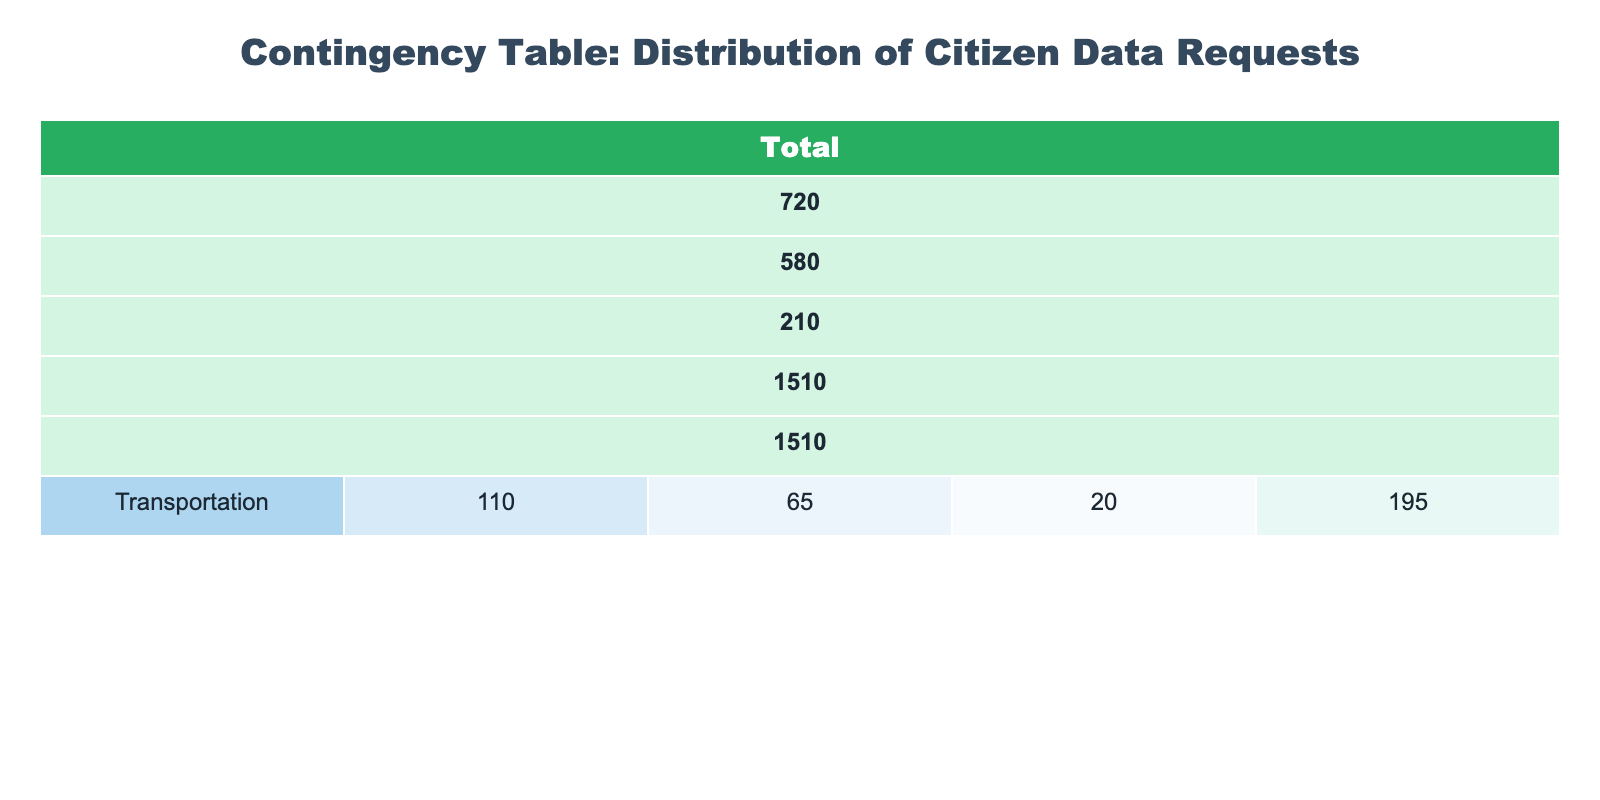What is the total number of high urgency requests across all departments? To find the total number of high urgency requests, I’ll add the values from the "High" column across all departments: 150 (Public Health) + 100 (Education) + 70 (Social Services) + 200 (Public Safety) + 90 (City Planning) + 110 (Transportation) = 720.
Answer: 720 Which department received the highest number of medium urgency requests? I will compare the medium urgency requests across departments: Public Health has 80, Education has 120, Social Services has 90, Public Safety has 150, City Planning has 75, and Transportation has 65. The highest number is 150 from the Public Safety department.
Answer: Public Safety Are there more low urgency requests in Education or Social Services? The low urgency requests in Education is 25, while Social Services has 40. Since 40 is greater than 25, there are more low urgency requests in Social Services.
Answer: Yes What is the average number of requests for the Public Health department? To calculate the average, I will sum the number of requests across urgency levels: 150 (High) + 80 (Medium) + 30 (Low) = 260. Then divide this total by the number of urgency categories (3). So, 260 / 3 = approximately 86.67.
Answer: 86.67 Which department has the lowest total number of requests, and what is the total? I will sum the number of requests for each department to find the total: Public Health (260), Education (245), Social Services (200), Public Safety (410), City Planning (200), Transportation (195). The lowest total is 195 from the Transportation department.
Answer: Transportation, 195 What is the difference in the number of high urgency requests between Public Safety and Education? The number of high urgency requests for Public Safety is 200 and for Education is 100. The difference is calculated by subtracting Education’s high requests from Public Safety’s: 200 - 100 = 100.
Answer: 100 Is the total number of requests in Transportation greater than the total number of requests in City Planning? The total for Transportation is 195 (110 + 65 + 20), and for City Planning is 200 (90 + 75 + 35). Since 195 is not greater than 200, the answer is no.
Answer: No Which urgency level received the least overall number of requests across all departments? I will sum the total requests for each urgency level: High (720 total), Medium (675 total), and Low (165 total). The lowest overall sum is for the Low urgency requests at 165.
Answer: Low When considering only high urgency requests, which department has the highest count? The counts for high urgency are: Public Health (150), Education (100), Social Services (70), Public Safety (200), City Planning (90), Transportation (110). Public Safety has the highest count at 200.
Answer: Public Safety 